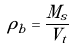Convert formula to latex. <formula><loc_0><loc_0><loc_500><loc_500>\rho _ { b } = \frac { M _ { s } } { V _ { t } }</formula> 